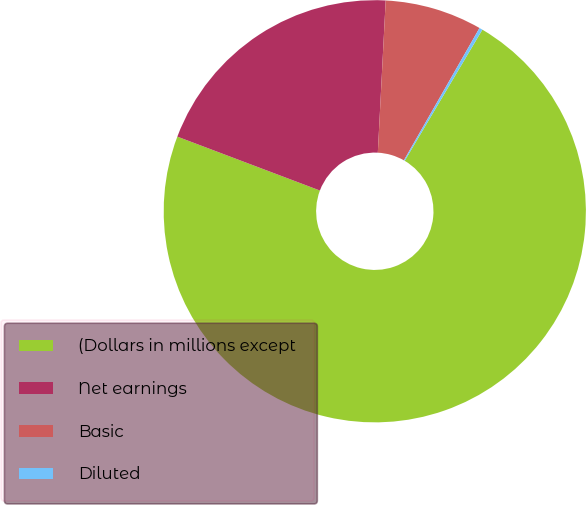<chart> <loc_0><loc_0><loc_500><loc_500><pie_chart><fcel>(Dollars in millions except<fcel>Net earnings<fcel>Basic<fcel>Diluted<nl><fcel>72.24%<fcel>20.07%<fcel>7.44%<fcel>0.25%<nl></chart> 